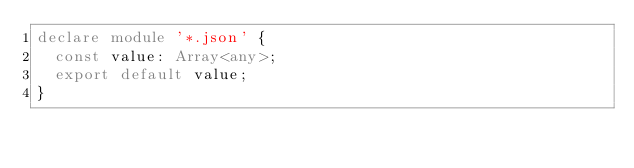<code> <loc_0><loc_0><loc_500><loc_500><_TypeScript_>declare module '*.json' {
  const value: Array<any>;
  export default value;
}
</code> 